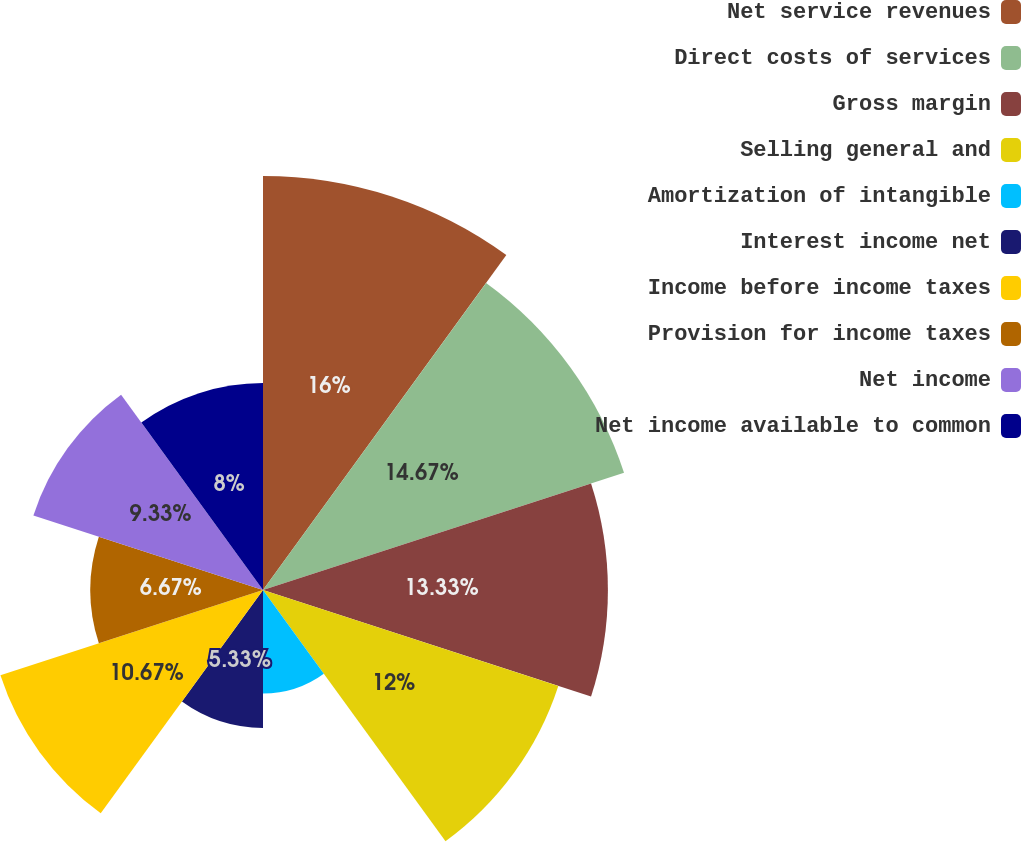<chart> <loc_0><loc_0><loc_500><loc_500><pie_chart><fcel>Net service revenues<fcel>Direct costs of services<fcel>Gross margin<fcel>Selling general and<fcel>Amortization of intangible<fcel>Interest income net<fcel>Income before income taxes<fcel>Provision for income taxes<fcel>Net income<fcel>Net income available to common<nl><fcel>16.0%<fcel>14.67%<fcel>13.33%<fcel>12.0%<fcel>4.0%<fcel>5.33%<fcel>10.67%<fcel>6.67%<fcel>9.33%<fcel>8.0%<nl></chart> 